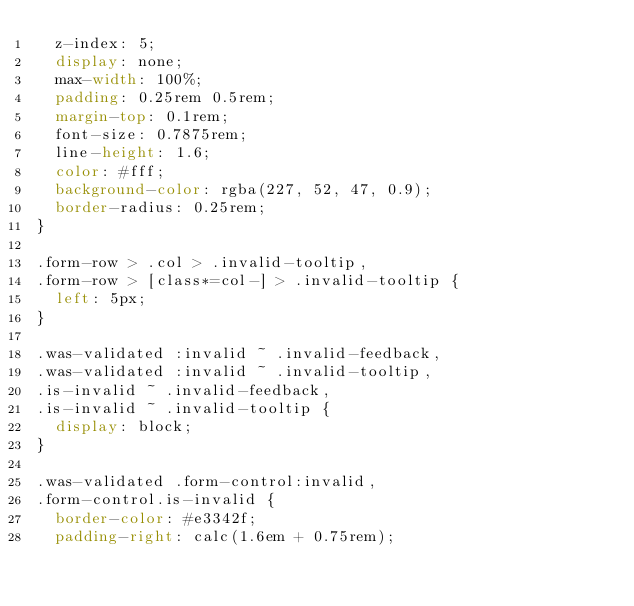Convert code to text. <code><loc_0><loc_0><loc_500><loc_500><_CSS_>  z-index: 5;
  display: none;
  max-width: 100%;
  padding: 0.25rem 0.5rem;
  margin-top: 0.1rem;
  font-size: 0.7875rem;
  line-height: 1.6;
  color: #fff;
  background-color: rgba(227, 52, 47, 0.9);
  border-radius: 0.25rem;
}

.form-row > .col > .invalid-tooltip,
.form-row > [class*=col-] > .invalid-tooltip {
  left: 5px;
}

.was-validated :invalid ~ .invalid-feedback,
.was-validated :invalid ~ .invalid-tooltip,
.is-invalid ~ .invalid-feedback,
.is-invalid ~ .invalid-tooltip {
  display: block;
}

.was-validated .form-control:invalid,
.form-control.is-invalid {
  border-color: #e3342f;
  padding-right: calc(1.6em + 0.75rem);</code> 